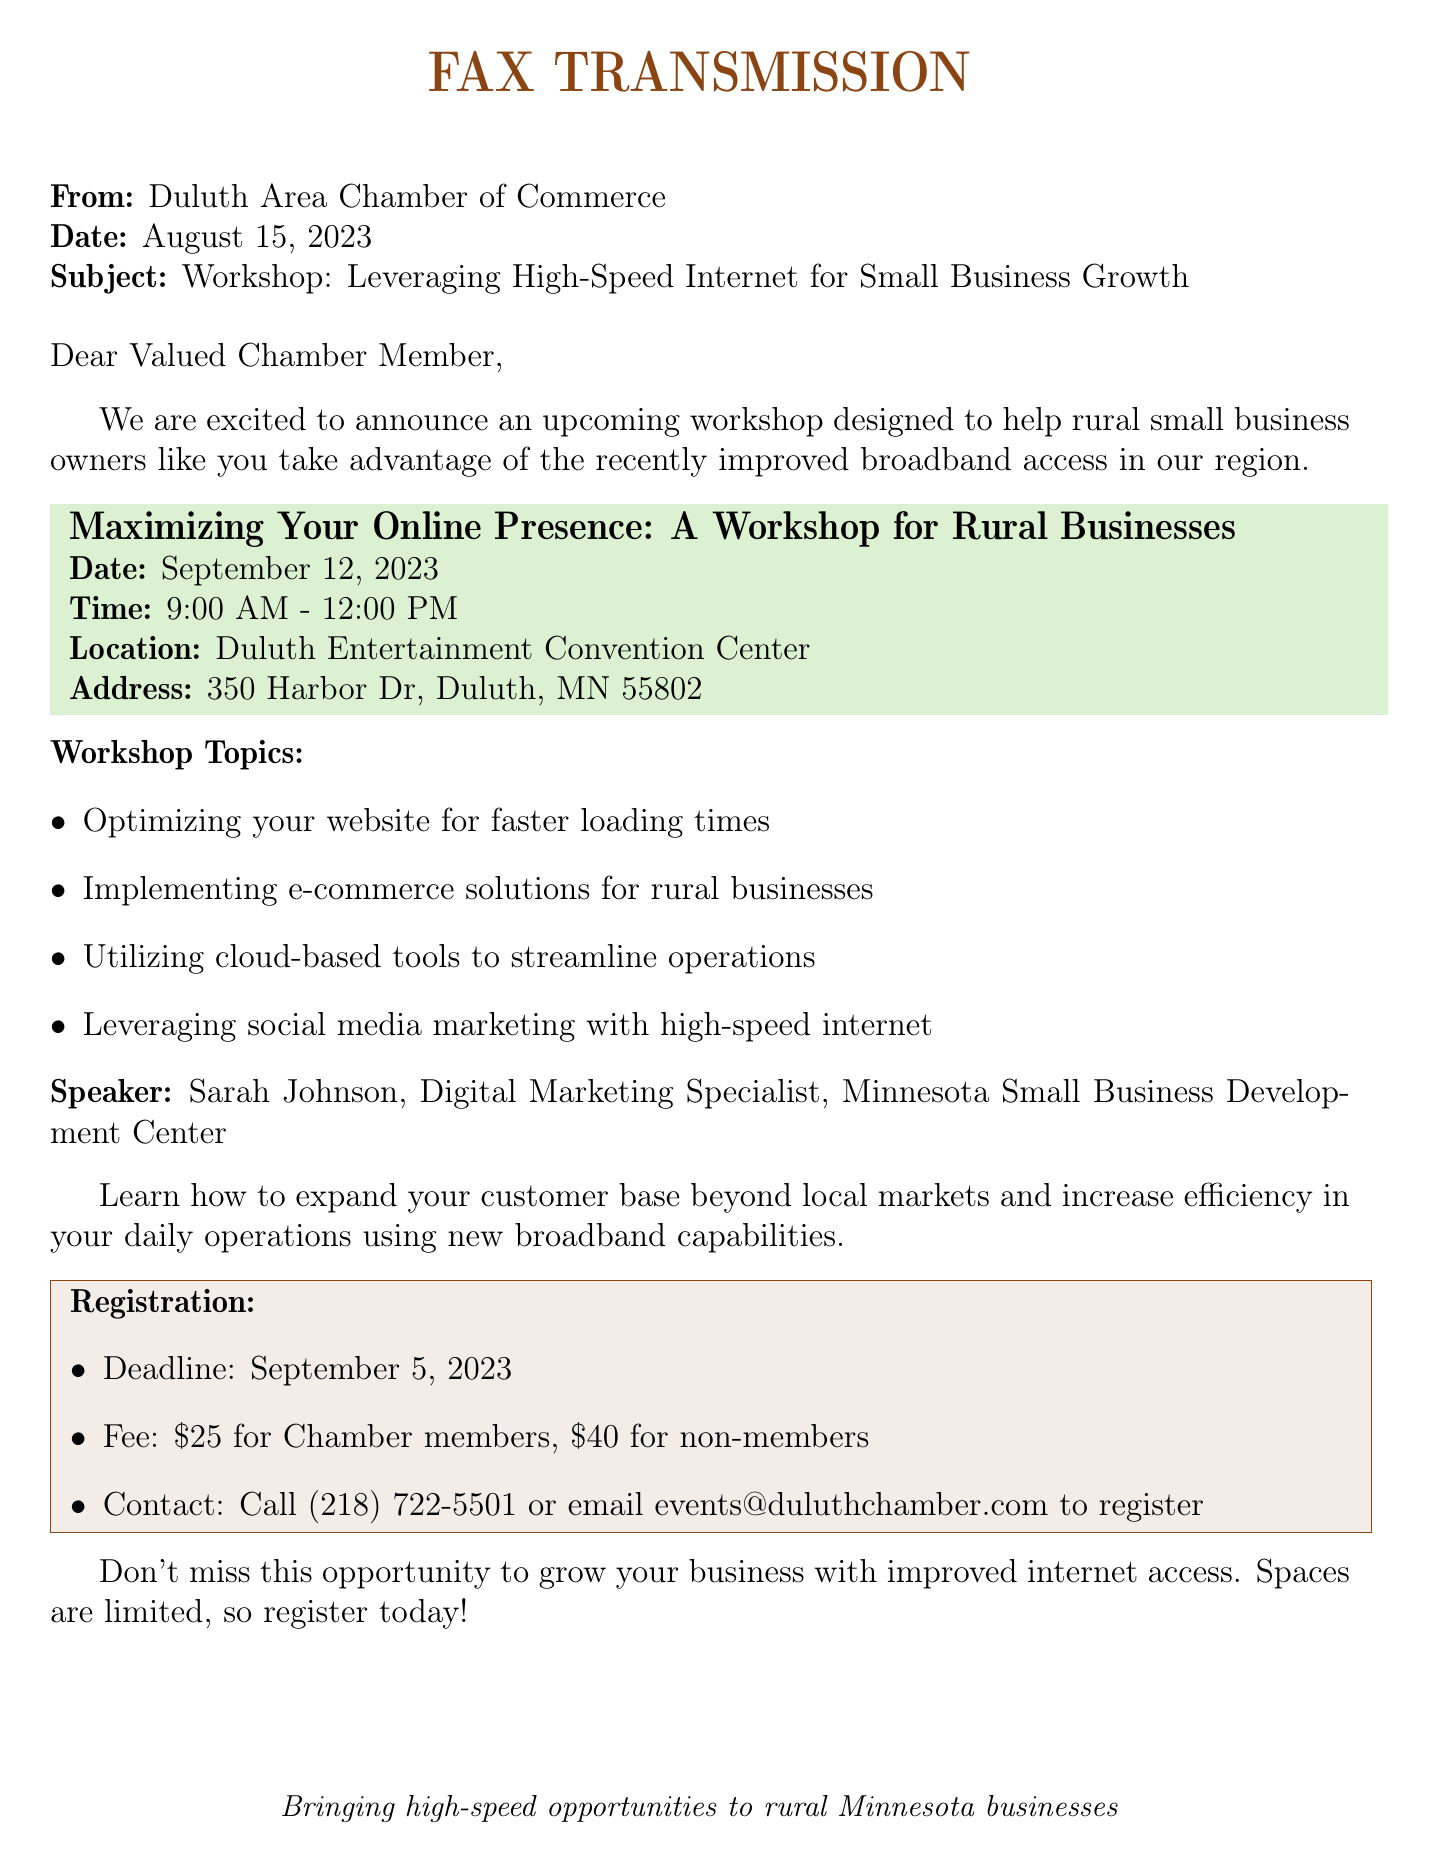What is the date of the workshop? The date of the workshop, as specified in the document, is September 12, 2023.
Answer: September 12, 2023 What is the workshop's starting time? The starting time of the workshop is found in the document under the workshop details, which states 9:00 AM.
Answer: 9:00 AM Who is the speaker at the workshop? The speaker's name is provided in the document, identifying Sarah Johnson as the Digital Marketing Specialist.
Answer: Sarah Johnson What is the registration deadline? The document specifies the registration deadline as September 5, 2023.
Answer: September 5, 2023 What is the fee for Chamber members? The fee for Chamber members is indicated in the registration section of the document, which is $25.
Answer: $25 What will attendees learn at the workshop? The document outlines that attendees will learn about expanding their customer base and increasing efficiency, utilizing improved broadband capabilities.
Answer: Expanding customer base and increasing efficiency What is the workshop's location? The location of the workshop is detailed in the document, which states Duluth Entertainment Convention Center.
Answer: Duluth Entertainment Convention Center What type of document is this? This document is identified as a fax transmission from the Duluth Area Chamber of Commerce regarding the workshop.
Answer: Fax transmission 